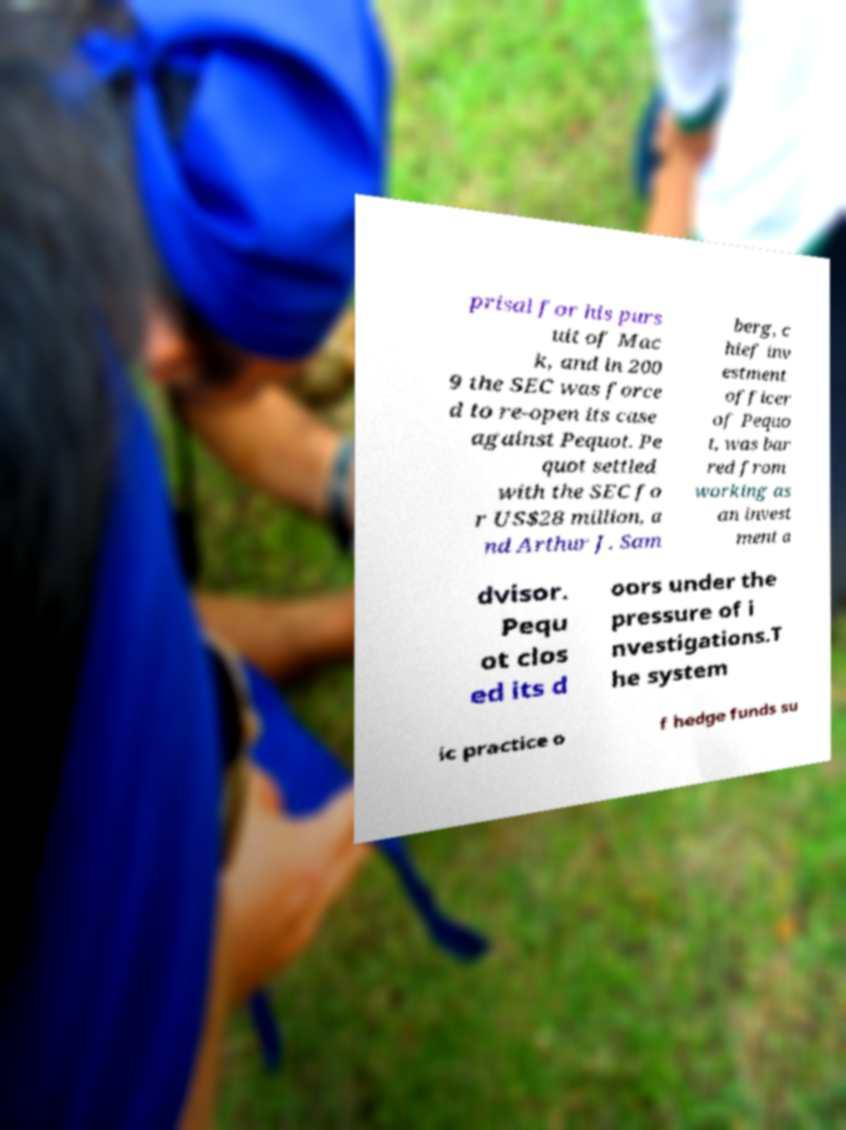For documentation purposes, I need the text within this image transcribed. Could you provide that? prisal for his purs uit of Mac k, and in 200 9 the SEC was force d to re-open its case against Pequot. Pe quot settled with the SEC fo r US$28 million, a nd Arthur J. Sam berg, c hief inv estment officer of Pequo t, was bar red from working as an invest ment a dvisor. Pequ ot clos ed its d oors under the pressure of i nvestigations.T he system ic practice o f hedge funds su 